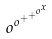<formula> <loc_0><loc_0><loc_500><loc_500>o ^ { o ^ { + ^ { + ^ { o ^ { x } } } } }</formula> 